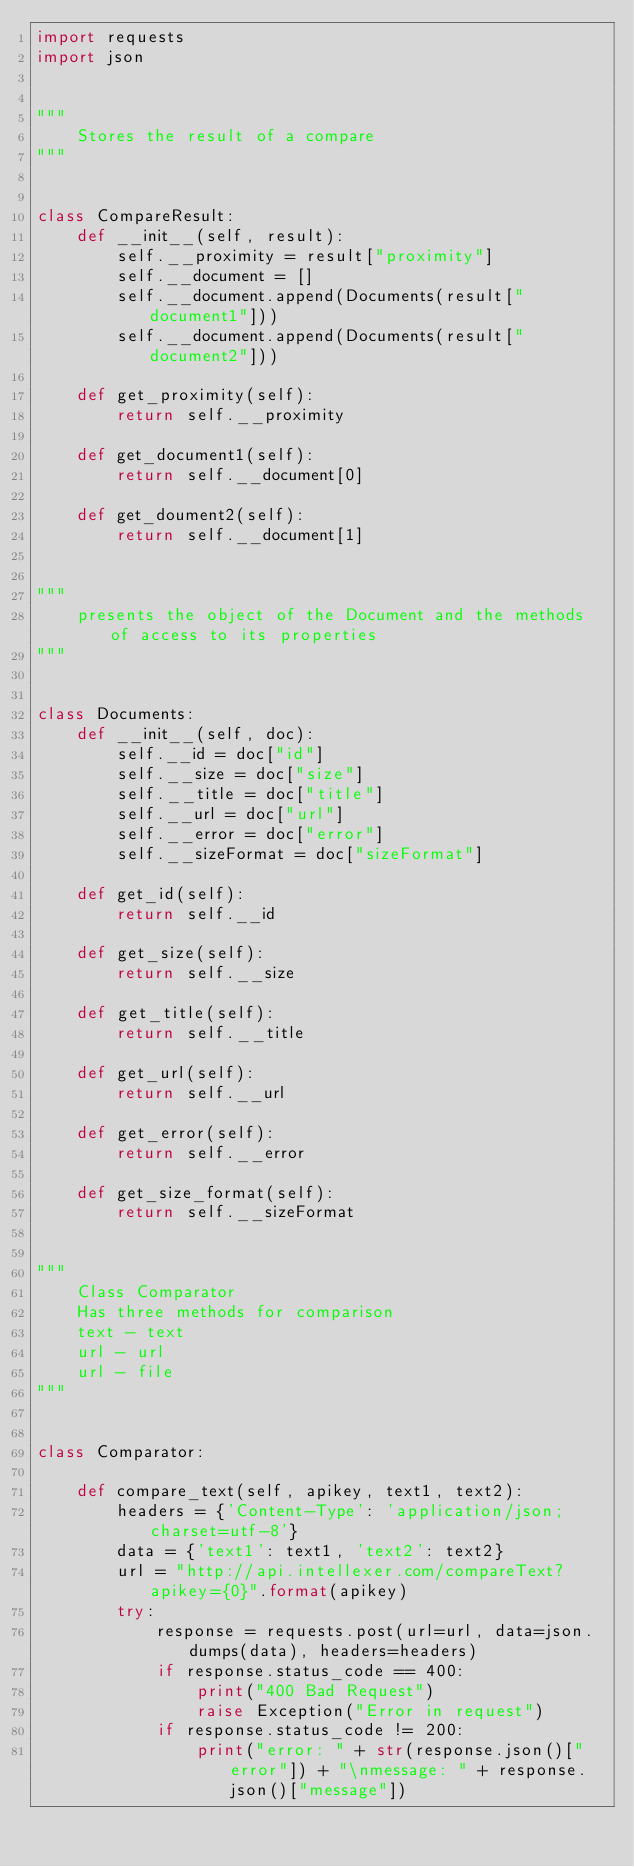<code> <loc_0><loc_0><loc_500><loc_500><_Python_>import requests
import json


"""
    Stores the result of a compare
"""


class CompareResult:
    def __init__(self, result):
        self.__proximity = result["proximity"]
        self.__document = []
        self.__document.append(Documents(result["document1"]))
        self.__document.append(Documents(result["document2"]))

    def get_proximity(self):
        return self.__proximity

    def get_document1(self):
        return self.__document[0]

    def get_doument2(self):
        return self.__document[1]


"""
    presents the object of the Document and the methods of access to its properties
"""


class Documents:
    def __init__(self, doc):
        self.__id = doc["id"]
        self.__size = doc["size"]
        self.__title = doc["title"]
        self.__url = doc["url"]
        self.__error = doc["error"]
        self.__sizeFormat = doc["sizeFormat"]

    def get_id(self):
        return self.__id

    def get_size(self):
        return self.__size

    def get_title(self):
        return self.__title

    def get_url(self):
        return self.__url

    def get_error(self):
        return self.__error

    def get_size_format(self):
        return self.__sizeFormat


"""
    Class Comparator
    Has three methods for comparison
    text - text
    url - url
    url - file
"""


class Comparator:

    def compare_text(self, apikey, text1, text2):
        headers = {'Content-Type': 'application/json; charset=utf-8'}
        data = {'text1': text1, 'text2': text2}
        url = "http://api.intellexer.com/compareText?apikey={0}".format(apikey)
        try:
            response = requests.post(url=url, data=json.dumps(data), headers=headers)
            if response.status_code == 400:
                print("400 Bad Request")
                raise Exception("Error in request")
            if response.status_code != 200:
                print("error: " + str(response.json()["error"]) + "\nmessage: " + response.json()["message"])</code> 